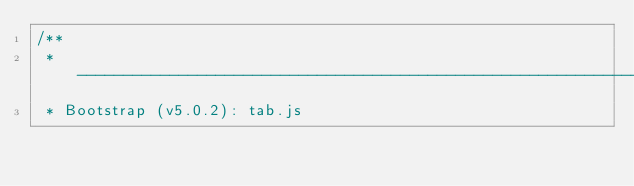Convert code to text. <code><loc_0><loc_0><loc_500><loc_500><_JavaScript_>/**
 * --------------------------------------------------------------------------
 * Bootstrap (v5.0.2): tab.js</code> 